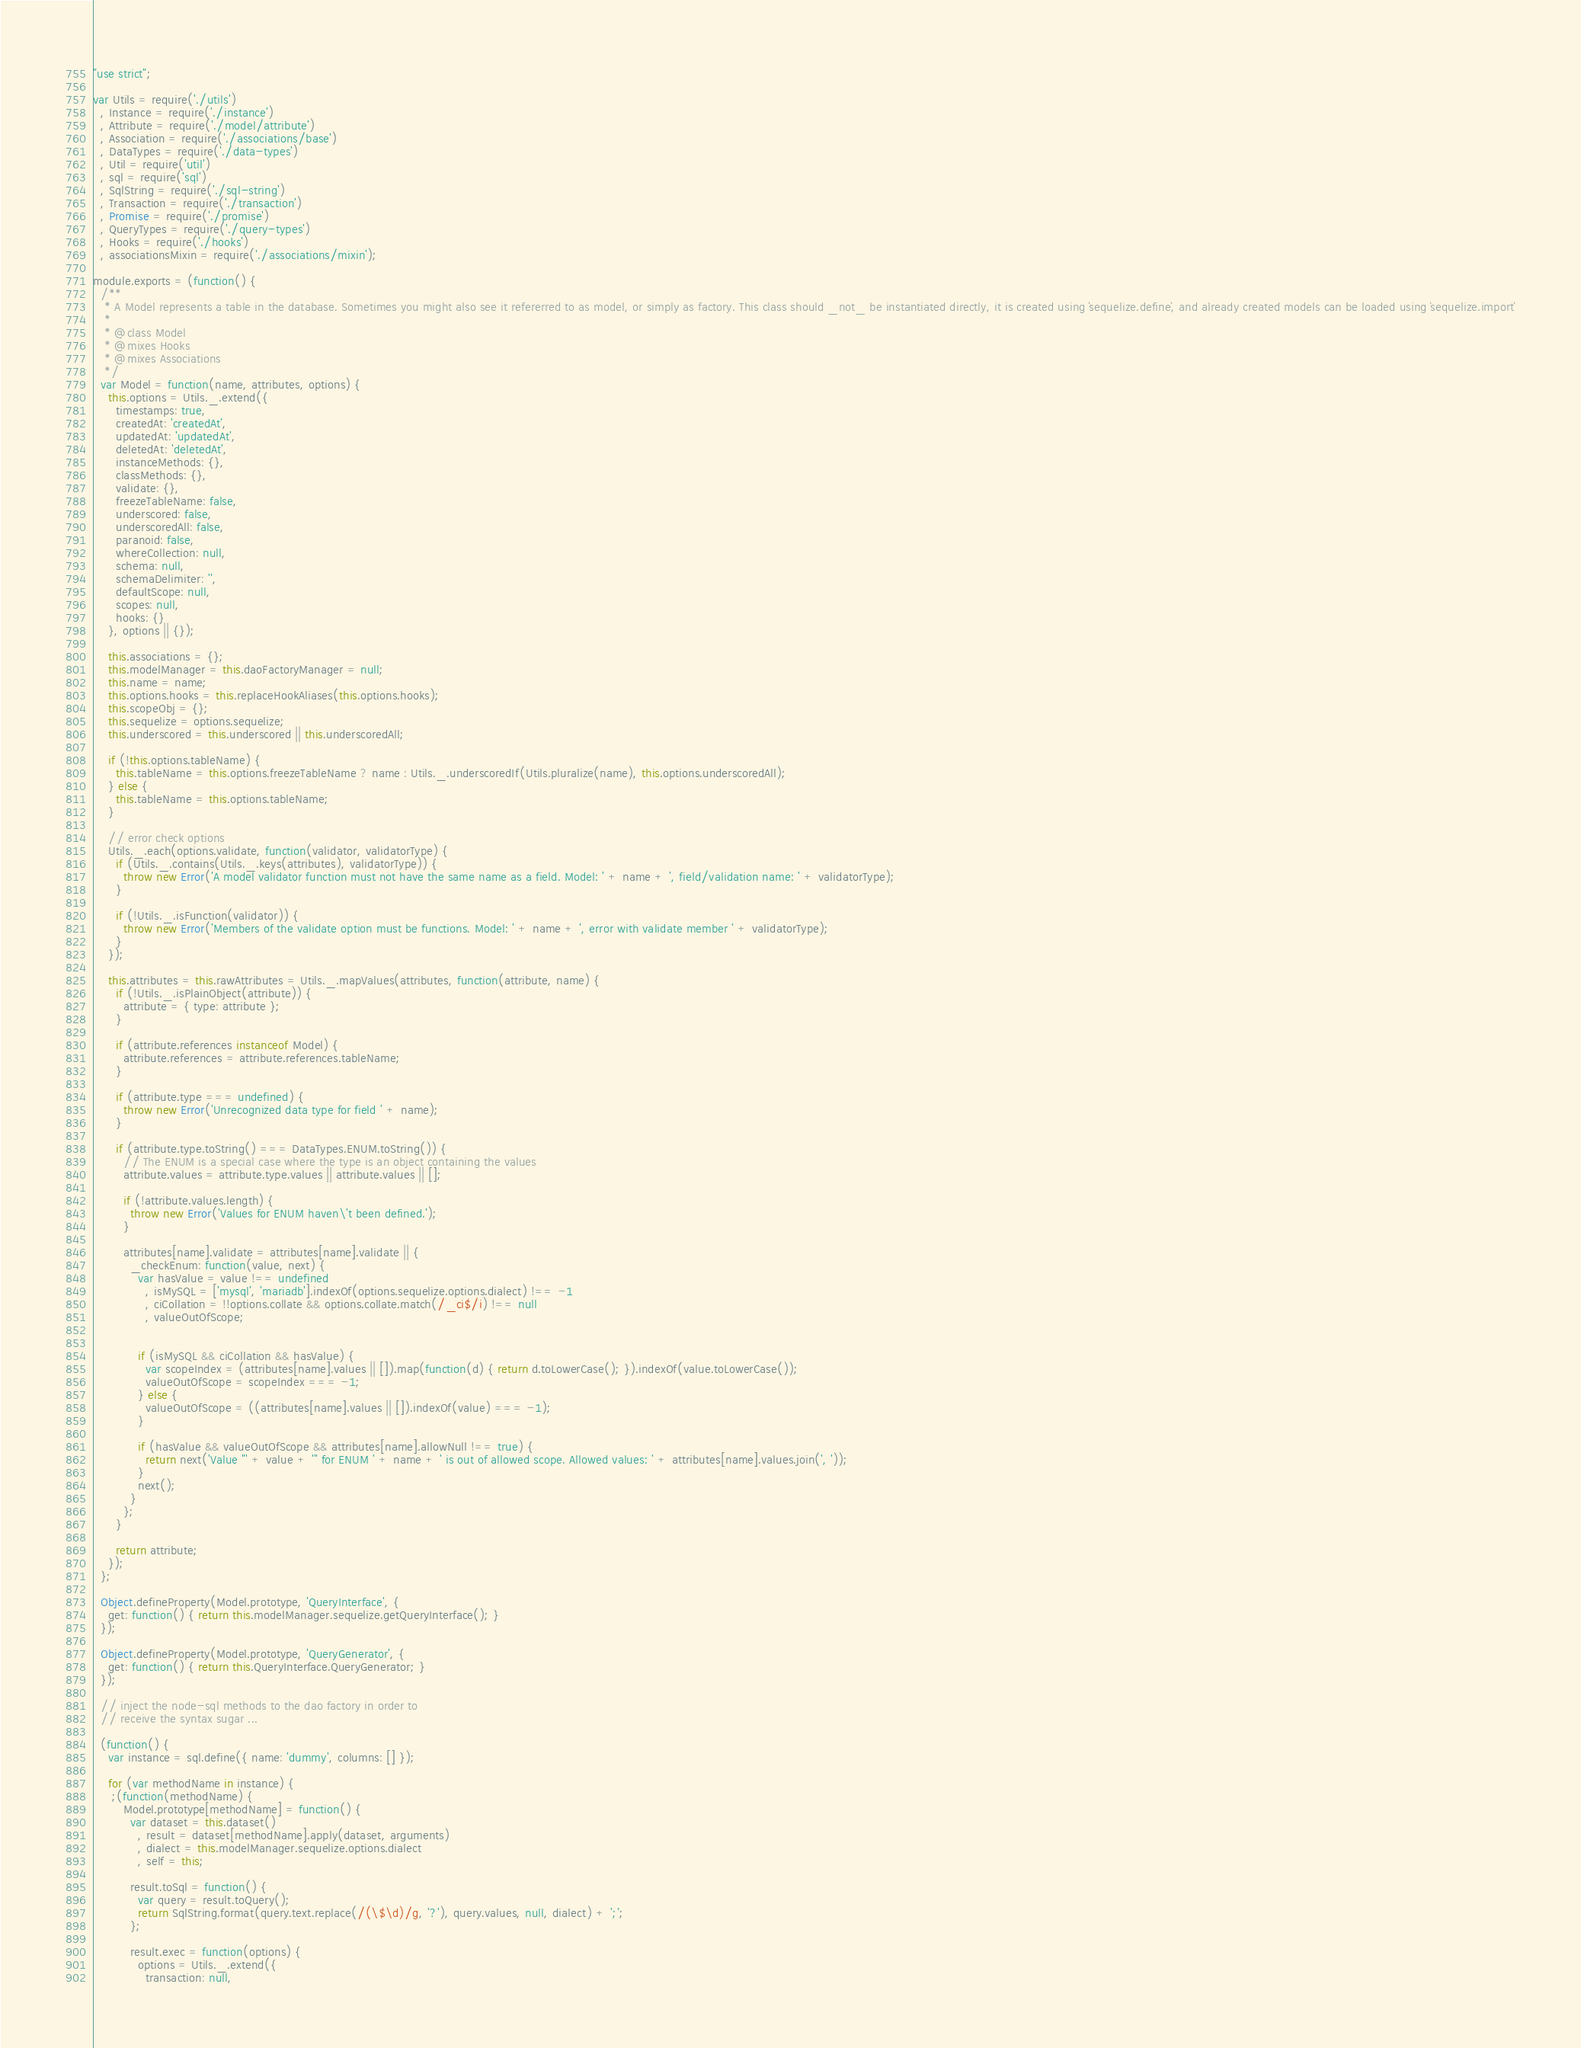Convert code to text. <code><loc_0><loc_0><loc_500><loc_500><_JavaScript_>"use strict";

var Utils = require('./utils')
  , Instance = require('./instance')
  , Attribute = require('./model/attribute')
  , Association = require('./associations/base')
  , DataTypes = require('./data-types')
  , Util = require('util')
  , sql = require('sql')
  , SqlString = require('./sql-string')
  , Transaction = require('./transaction')
  , Promise = require('./promise')
  , QueryTypes = require('./query-types')
  , Hooks = require('./hooks')
  , associationsMixin = require('./associations/mixin');

module.exports = (function() {
  /**
   * A Model represents a table in the database. Sometimes you might also see it refererred to as model, or simply as factory. This class should _not_ be instantiated directly, it is created using `sequelize.define`, and already created models can be loaded using `sequelize.import`
   *
   * @class Model
   * @mixes Hooks
   * @mixes Associations
   */
  var Model = function(name, attributes, options) {
    this.options = Utils._.extend({
      timestamps: true,
      createdAt: 'createdAt',
      updatedAt: 'updatedAt',
      deletedAt: 'deletedAt',
      instanceMethods: {},
      classMethods: {},
      validate: {},
      freezeTableName: false,
      underscored: false,
      underscoredAll: false,
      paranoid: false,
      whereCollection: null,
      schema: null,
      schemaDelimiter: '',
      defaultScope: null,
      scopes: null,
      hooks: {}
    }, options || {});

    this.associations = {};
    this.modelManager = this.daoFactoryManager = null;
    this.name = name;
    this.options.hooks = this.replaceHookAliases(this.options.hooks);
    this.scopeObj = {};
    this.sequelize = options.sequelize;
    this.underscored = this.underscored || this.underscoredAll;

    if (!this.options.tableName) {
      this.tableName = this.options.freezeTableName ? name : Utils._.underscoredIf(Utils.pluralize(name), this.options.underscoredAll);
    } else {
      this.tableName = this.options.tableName;
    }

    // error check options
    Utils._.each(options.validate, function(validator, validatorType) {
      if (Utils._.contains(Utils._.keys(attributes), validatorType)) {
        throw new Error('A model validator function must not have the same name as a field. Model: ' + name + ', field/validation name: ' + validatorType);
      }

      if (!Utils._.isFunction(validator)) {
        throw new Error('Members of the validate option must be functions. Model: ' + name + ', error with validate member ' + validatorType);
      }
    });

    this.attributes = this.rawAttributes = Utils._.mapValues(attributes, function(attribute, name) {
      if (!Utils._.isPlainObject(attribute)) {
        attribute = { type: attribute };
      }

      if (attribute.references instanceof Model) {
        attribute.references = attribute.references.tableName;
      }

      if (attribute.type === undefined) {
        throw new Error('Unrecognized data type for field ' + name);
      }

      if (attribute.type.toString() === DataTypes.ENUM.toString()) {
        // The ENUM is a special case where the type is an object containing the values
        attribute.values = attribute.type.values || attribute.values || [];

        if (!attribute.values.length) {
          throw new Error('Values for ENUM haven\'t been defined.');
        }

        attributes[name].validate = attributes[name].validate || {
          _checkEnum: function(value, next) {
            var hasValue = value !== undefined
              , isMySQL = ['mysql', 'mariadb'].indexOf(options.sequelize.options.dialect) !== -1
              , ciCollation = !!options.collate && options.collate.match(/_ci$/i) !== null
              , valueOutOfScope;


            if (isMySQL && ciCollation && hasValue) {
              var scopeIndex = (attributes[name].values || []).map(function(d) { return d.toLowerCase(); }).indexOf(value.toLowerCase());
              valueOutOfScope = scopeIndex === -1;
            } else {
              valueOutOfScope = ((attributes[name].values || []).indexOf(value) === -1);
            }

            if (hasValue && valueOutOfScope && attributes[name].allowNull !== true) {
              return next('Value "' + value + '" for ENUM ' + name + ' is out of allowed scope. Allowed values: ' + attributes[name].values.join(', '));
            }
            next();
          }
        };
      }

      return attribute;
    });
  };

  Object.defineProperty(Model.prototype, 'QueryInterface', {
    get: function() { return this.modelManager.sequelize.getQueryInterface(); }
  });

  Object.defineProperty(Model.prototype, 'QueryGenerator', {
    get: function() { return this.QueryInterface.QueryGenerator; }
  });

  // inject the node-sql methods to the dao factory in order to
  // receive the syntax sugar ...

  (function() {
    var instance = sql.define({ name: 'dummy', columns: [] });

    for (var methodName in instance) {
     ;(function(methodName) {
        Model.prototype[methodName] = function() {
          var dataset = this.dataset()
            , result = dataset[methodName].apply(dataset, arguments)
            , dialect = this.modelManager.sequelize.options.dialect
            , self = this;

          result.toSql = function() {
            var query = result.toQuery();
            return SqlString.format(query.text.replace(/(\$\d)/g, '?'), query.values, null, dialect) + ';';
          };

          result.exec = function(options) {
            options = Utils._.extend({
              transaction: null,</code> 